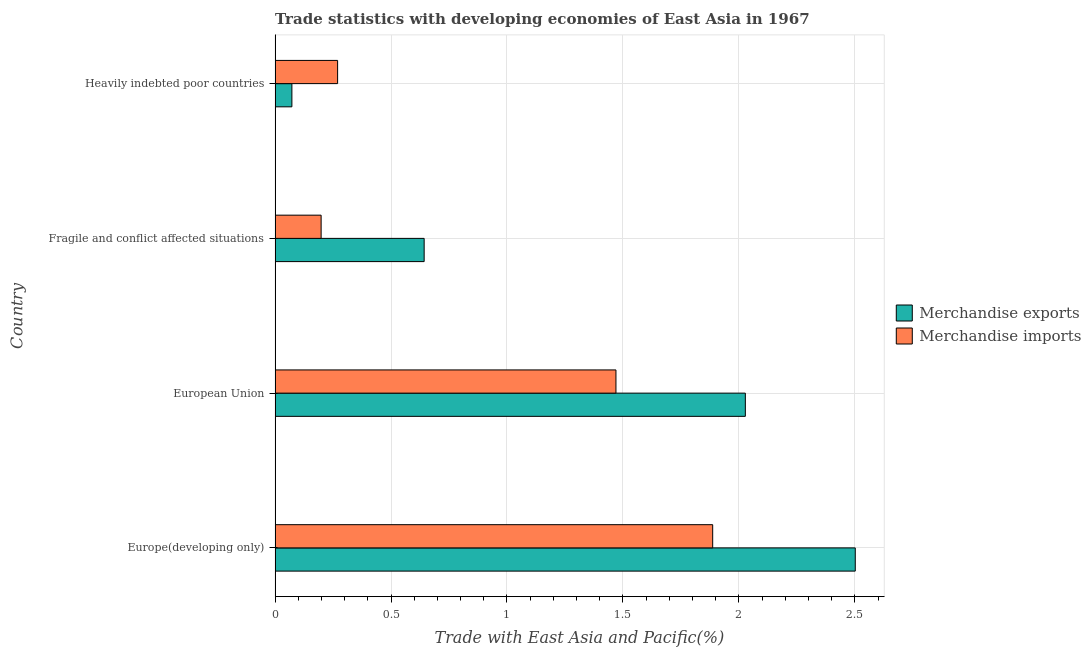How many groups of bars are there?
Ensure brevity in your answer.  4. How many bars are there on the 4th tick from the bottom?
Your answer should be very brief. 2. What is the label of the 4th group of bars from the top?
Your response must be concise. Europe(developing only). What is the merchandise imports in Europe(developing only)?
Make the answer very short. 1.89. Across all countries, what is the maximum merchandise imports?
Provide a succinct answer. 1.89. Across all countries, what is the minimum merchandise imports?
Give a very brief answer. 0.2. In which country was the merchandise imports maximum?
Give a very brief answer. Europe(developing only). In which country was the merchandise imports minimum?
Give a very brief answer. Fragile and conflict affected situations. What is the total merchandise exports in the graph?
Ensure brevity in your answer.  5.25. What is the difference between the merchandise exports in Fragile and conflict affected situations and that in Heavily indebted poor countries?
Provide a succinct answer. 0.57. What is the difference between the merchandise imports in Europe(developing only) and the merchandise exports in Fragile and conflict affected situations?
Your response must be concise. 1.24. What is the average merchandise exports per country?
Offer a terse response. 1.31. What is the difference between the merchandise imports and merchandise exports in European Union?
Give a very brief answer. -0.56. In how many countries, is the merchandise imports greater than 2.2 %?
Your answer should be compact. 0. What is the ratio of the merchandise imports in European Union to that in Heavily indebted poor countries?
Provide a short and direct response. 5.45. Is the merchandise imports in Fragile and conflict affected situations less than that in Heavily indebted poor countries?
Your response must be concise. Yes. Is the difference between the merchandise imports in Europe(developing only) and Fragile and conflict affected situations greater than the difference between the merchandise exports in Europe(developing only) and Fragile and conflict affected situations?
Provide a short and direct response. No. What is the difference between the highest and the second highest merchandise exports?
Offer a terse response. 0.47. What is the difference between the highest and the lowest merchandise exports?
Keep it short and to the point. 2.43. In how many countries, is the merchandise exports greater than the average merchandise exports taken over all countries?
Offer a very short reply. 2. Is the sum of the merchandise imports in European Union and Fragile and conflict affected situations greater than the maximum merchandise exports across all countries?
Offer a very short reply. No. What does the 2nd bar from the bottom in Europe(developing only) represents?
Make the answer very short. Merchandise imports. Are all the bars in the graph horizontal?
Make the answer very short. Yes. How many countries are there in the graph?
Your response must be concise. 4. Are the values on the major ticks of X-axis written in scientific E-notation?
Ensure brevity in your answer.  No. Does the graph contain any zero values?
Ensure brevity in your answer.  No. Does the graph contain grids?
Ensure brevity in your answer.  Yes. Where does the legend appear in the graph?
Keep it short and to the point. Center right. What is the title of the graph?
Offer a terse response. Trade statistics with developing economies of East Asia in 1967. What is the label or title of the X-axis?
Your answer should be compact. Trade with East Asia and Pacific(%). What is the label or title of the Y-axis?
Provide a succinct answer. Country. What is the Trade with East Asia and Pacific(%) of Merchandise exports in Europe(developing only)?
Offer a terse response. 2.5. What is the Trade with East Asia and Pacific(%) in Merchandise imports in Europe(developing only)?
Offer a very short reply. 1.89. What is the Trade with East Asia and Pacific(%) of Merchandise exports in European Union?
Make the answer very short. 2.03. What is the Trade with East Asia and Pacific(%) in Merchandise imports in European Union?
Give a very brief answer. 1.47. What is the Trade with East Asia and Pacific(%) in Merchandise exports in Fragile and conflict affected situations?
Keep it short and to the point. 0.64. What is the Trade with East Asia and Pacific(%) in Merchandise imports in Fragile and conflict affected situations?
Your answer should be compact. 0.2. What is the Trade with East Asia and Pacific(%) in Merchandise exports in Heavily indebted poor countries?
Offer a terse response. 0.07. What is the Trade with East Asia and Pacific(%) of Merchandise imports in Heavily indebted poor countries?
Offer a very short reply. 0.27. Across all countries, what is the maximum Trade with East Asia and Pacific(%) of Merchandise exports?
Offer a terse response. 2.5. Across all countries, what is the maximum Trade with East Asia and Pacific(%) in Merchandise imports?
Provide a short and direct response. 1.89. Across all countries, what is the minimum Trade with East Asia and Pacific(%) of Merchandise exports?
Give a very brief answer. 0.07. Across all countries, what is the minimum Trade with East Asia and Pacific(%) of Merchandise imports?
Offer a very short reply. 0.2. What is the total Trade with East Asia and Pacific(%) in Merchandise exports in the graph?
Offer a terse response. 5.25. What is the total Trade with East Asia and Pacific(%) in Merchandise imports in the graph?
Your response must be concise. 3.83. What is the difference between the Trade with East Asia and Pacific(%) of Merchandise exports in Europe(developing only) and that in European Union?
Provide a succinct answer. 0.47. What is the difference between the Trade with East Asia and Pacific(%) in Merchandise imports in Europe(developing only) and that in European Union?
Your answer should be compact. 0.42. What is the difference between the Trade with East Asia and Pacific(%) of Merchandise exports in Europe(developing only) and that in Fragile and conflict affected situations?
Your response must be concise. 1.86. What is the difference between the Trade with East Asia and Pacific(%) of Merchandise imports in Europe(developing only) and that in Fragile and conflict affected situations?
Provide a succinct answer. 1.69. What is the difference between the Trade with East Asia and Pacific(%) of Merchandise exports in Europe(developing only) and that in Heavily indebted poor countries?
Provide a short and direct response. 2.43. What is the difference between the Trade with East Asia and Pacific(%) in Merchandise imports in Europe(developing only) and that in Heavily indebted poor countries?
Your answer should be very brief. 1.62. What is the difference between the Trade with East Asia and Pacific(%) of Merchandise exports in European Union and that in Fragile and conflict affected situations?
Provide a succinct answer. 1.39. What is the difference between the Trade with East Asia and Pacific(%) in Merchandise imports in European Union and that in Fragile and conflict affected situations?
Make the answer very short. 1.27. What is the difference between the Trade with East Asia and Pacific(%) of Merchandise exports in European Union and that in Heavily indebted poor countries?
Offer a terse response. 1.96. What is the difference between the Trade with East Asia and Pacific(%) in Merchandise imports in European Union and that in Heavily indebted poor countries?
Ensure brevity in your answer.  1.2. What is the difference between the Trade with East Asia and Pacific(%) of Merchandise exports in Fragile and conflict affected situations and that in Heavily indebted poor countries?
Ensure brevity in your answer.  0.57. What is the difference between the Trade with East Asia and Pacific(%) in Merchandise imports in Fragile and conflict affected situations and that in Heavily indebted poor countries?
Your answer should be very brief. -0.07. What is the difference between the Trade with East Asia and Pacific(%) of Merchandise exports in Europe(developing only) and the Trade with East Asia and Pacific(%) of Merchandise imports in European Union?
Keep it short and to the point. 1.03. What is the difference between the Trade with East Asia and Pacific(%) in Merchandise exports in Europe(developing only) and the Trade with East Asia and Pacific(%) in Merchandise imports in Fragile and conflict affected situations?
Your response must be concise. 2.3. What is the difference between the Trade with East Asia and Pacific(%) in Merchandise exports in Europe(developing only) and the Trade with East Asia and Pacific(%) in Merchandise imports in Heavily indebted poor countries?
Give a very brief answer. 2.23. What is the difference between the Trade with East Asia and Pacific(%) of Merchandise exports in European Union and the Trade with East Asia and Pacific(%) of Merchandise imports in Fragile and conflict affected situations?
Give a very brief answer. 1.83. What is the difference between the Trade with East Asia and Pacific(%) of Merchandise exports in European Union and the Trade with East Asia and Pacific(%) of Merchandise imports in Heavily indebted poor countries?
Your answer should be very brief. 1.76. What is the difference between the Trade with East Asia and Pacific(%) in Merchandise exports in Fragile and conflict affected situations and the Trade with East Asia and Pacific(%) in Merchandise imports in Heavily indebted poor countries?
Make the answer very short. 0.37. What is the average Trade with East Asia and Pacific(%) of Merchandise exports per country?
Offer a very short reply. 1.31. What is the average Trade with East Asia and Pacific(%) of Merchandise imports per country?
Your answer should be very brief. 0.96. What is the difference between the Trade with East Asia and Pacific(%) of Merchandise exports and Trade with East Asia and Pacific(%) of Merchandise imports in Europe(developing only)?
Your answer should be compact. 0.61. What is the difference between the Trade with East Asia and Pacific(%) in Merchandise exports and Trade with East Asia and Pacific(%) in Merchandise imports in European Union?
Provide a succinct answer. 0.56. What is the difference between the Trade with East Asia and Pacific(%) of Merchandise exports and Trade with East Asia and Pacific(%) of Merchandise imports in Fragile and conflict affected situations?
Your answer should be compact. 0.44. What is the difference between the Trade with East Asia and Pacific(%) of Merchandise exports and Trade with East Asia and Pacific(%) of Merchandise imports in Heavily indebted poor countries?
Provide a succinct answer. -0.2. What is the ratio of the Trade with East Asia and Pacific(%) of Merchandise exports in Europe(developing only) to that in European Union?
Provide a succinct answer. 1.23. What is the ratio of the Trade with East Asia and Pacific(%) of Merchandise imports in Europe(developing only) to that in European Union?
Your response must be concise. 1.28. What is the ratio of the Trade with East Asia and Pacific(%) in Merchandise exports in Europe(developing only) to that in Fragile and conflict affected situations?
Ensure brevity in your answer.  3.89. What is the ratio of the Trade with East Asia and Pacific(%) in Merchandise imports in Europe(developing only) to that in Fragile and conflict affected situations?
Your answer should be compact. 9.5. What is the ratio of the Trade with East Asia and Pacific(%) in Merchandise exports in Europe(developing only) to that in Heavily indebted poor countries?
Provide a short and direct response. 34.51. What is the ratio of the Trade with East Asia and Pacific(%) in Merchandise imports in Europe(developing only) to that in Heavily indebted poor countries?
Your answer should be compact. 7. What is the ratio of the Trade with East Asia and Pacific(%) of Merchandise exports in European Union to that in Fragile and conflict affected situations?
Your response must be concise. 3.15. What is the ratio of the Trade with East Asia and Pacific(%) in Merchandise imports in European Union to that in Fragile and conflict affected situations?
Offer a terse response. 7.4. What is the ratio of the Trade with East Asia and Pacific(%) in Merchandise exports in European Union to that in Heavily indebted poor countries?
Your response must be concise. 27.97. What is the ratio of the Trade with East Asia and Pacific(%) in Merchandise imports in European Union to that in Heavily indebted poor countries?
Offer a very short reply. 5.45. What is the ratio of the Trade with East Asia and Pacific(%) of Merchandise exports in Fragile and conflict affected situations to that in Heavily indebted poor countries?
Keep it short and to the point. 8.87. What is the ratio of the Trade with East Asia and Pacific(%) in Merchandise imports in Fragile and conflict affected situations to that in Heavily indebted poor countries?
Your answer should be very brief. 0.74. What is the difference between the highest and the second highest Trade with East Asia and Pacific(%) in Merchandise exports?
Give a very brief answer. 0.47. What is the difference between the highest and the second highest Trade with East Asia and Pacific(%) in Merchandise imports?
Make the answer very short. 0.42. What is the difference between the highest and the lowest Trade with East Asia and Pacific(%) of Merchandise exports?
Give a very brief answer. 2.43. What is the difference between the highest and the lowest Trade with East Asia and Pacific(%) in Merchandise imports?
Ensure brevity in your answer.  1.69. 